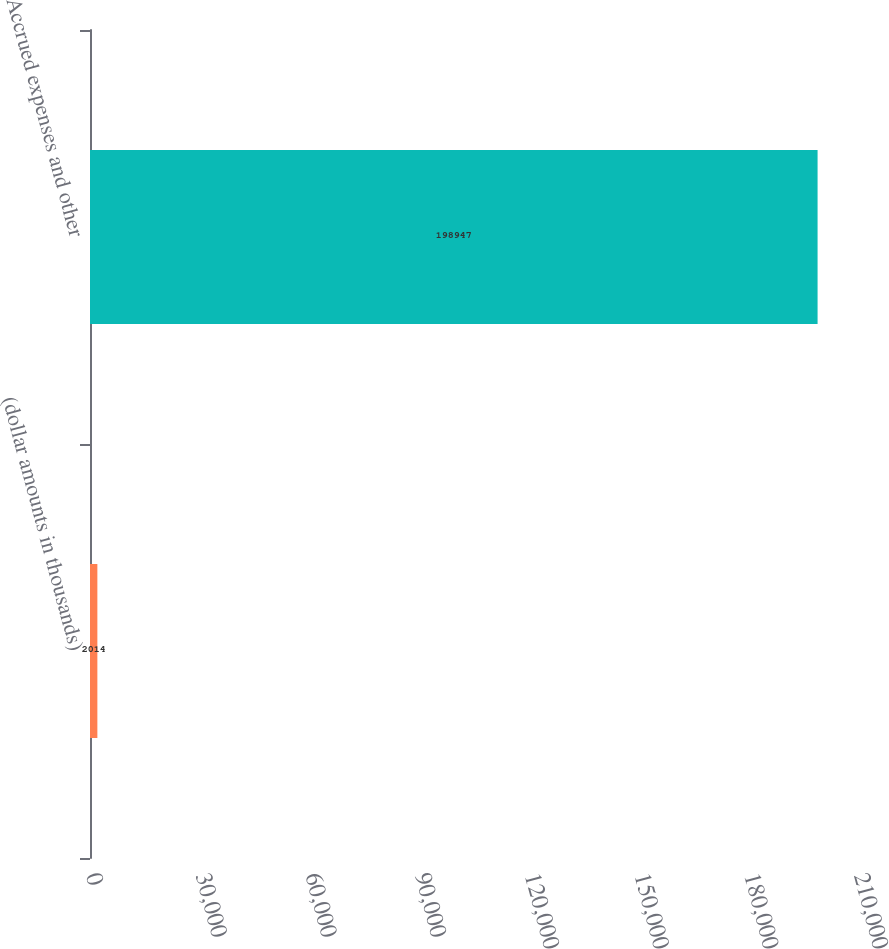<chart> <loc_0><loc_0><loc_500><loc_500><bar_chart><fcel>(dollar amounts in thousands)<fcel>Accrued expenses and other<nl><fcel>2014<fcel>198947<nl></chart> 